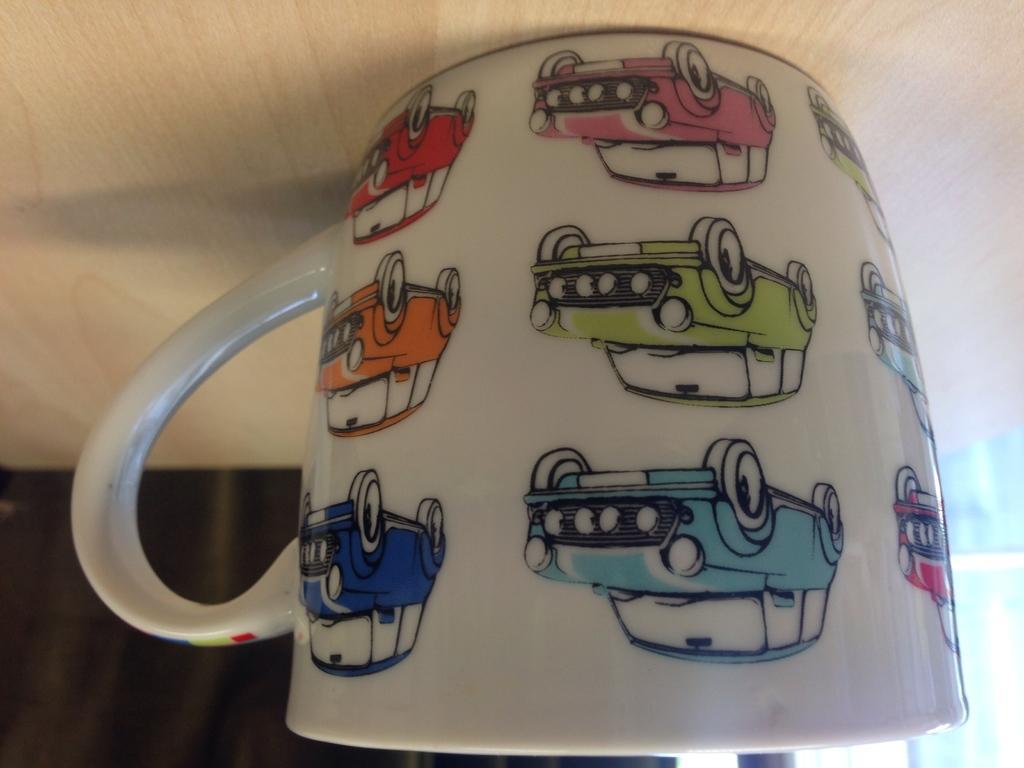Describe this image in one or two sentences. In this image we can see a cup on the wooden surface, there are some car images on the cup. 